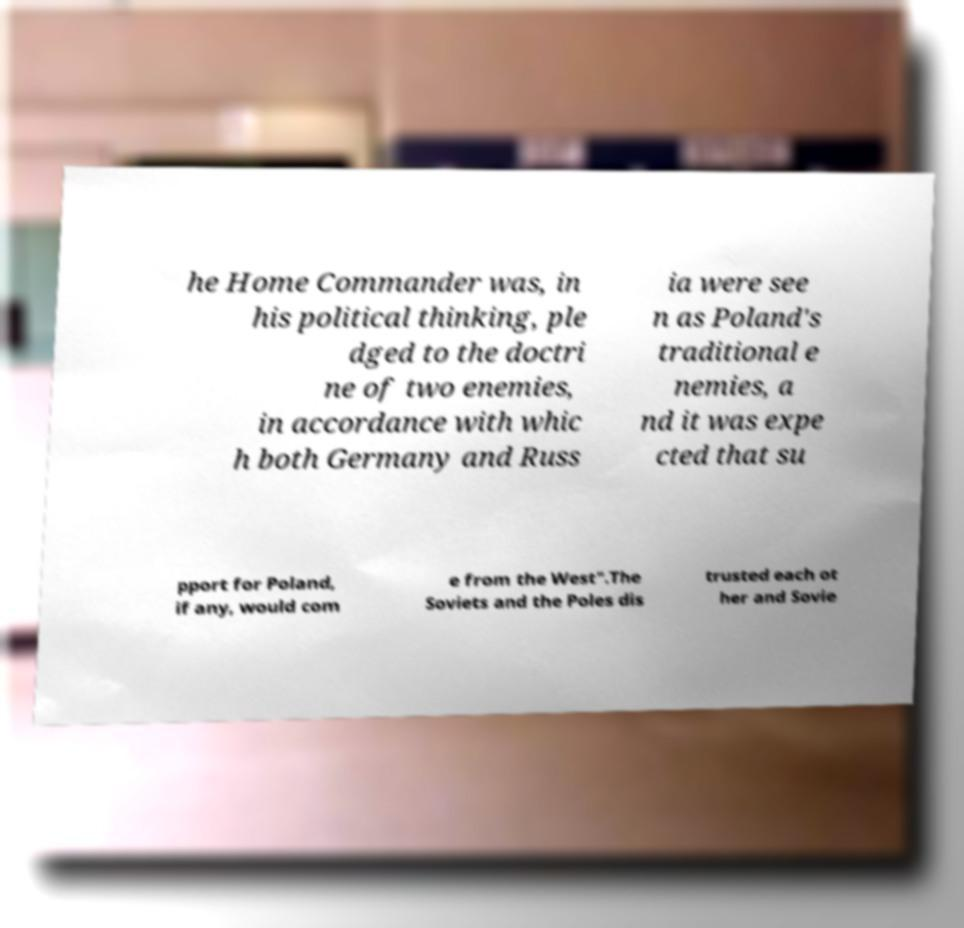For documentation purposes, I need the text within this image transcribed. Could you provide that? he Home Commander was, in his political thinking, ple dged to the doctri ne of two enemies, in accordance with whic h both Germany and Russ ia were see n as Poland's traditional e nemies, a nd it was expe cted that su pport for Poland, if any, would com e from the West".The Soviets and the Poles dis trusted each ot her and Sovie 